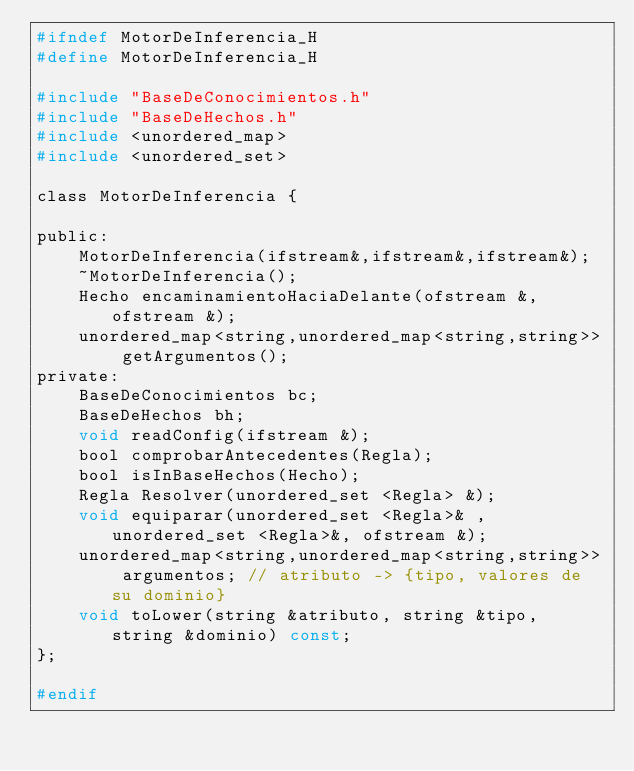Convert code to text. <code><loc_0><loc_0><loc_500><loc_500><_C_>#ifndef MotorDeInferencia_H
#define MotorDeInferencia_H

#include "BaseDeConocimientos.h"
#include "BaseDeHechos.h"
#include <unordered_map>
#include <unordered_set>

class MotorDeInferencia {

public:
	MotorDeInferencia(ifstream&,ifstream&,ifstream&);
    ~MotorDeInferencia();
    Hecho encaminamientoHaciaDelante(ofstream &,ofstream &);
    unordered_map<string,unordered_map<string,string>> getArgumentos();
private:
    BaseDeConocimientos bc;
    BaseDeHechos bh;
    void readConfig(ifstream &);
    bool comprobarAntecedentes(Regla);
    bool isInBaseHechos(Hecho);
    Regla Resolver(unordered_set <Regla> &);
    void equiparar(unordered_set <Regla>& ,unordered_set <Regla>&, ofstream &);
    unordered_map<string,unordered_map<string,string>> argumentos; // atributo -> {tipo, valores de su dominio}
    void toLower(string &atributo, string &tipo, string &dominio) const;
};

#endif
</code> 